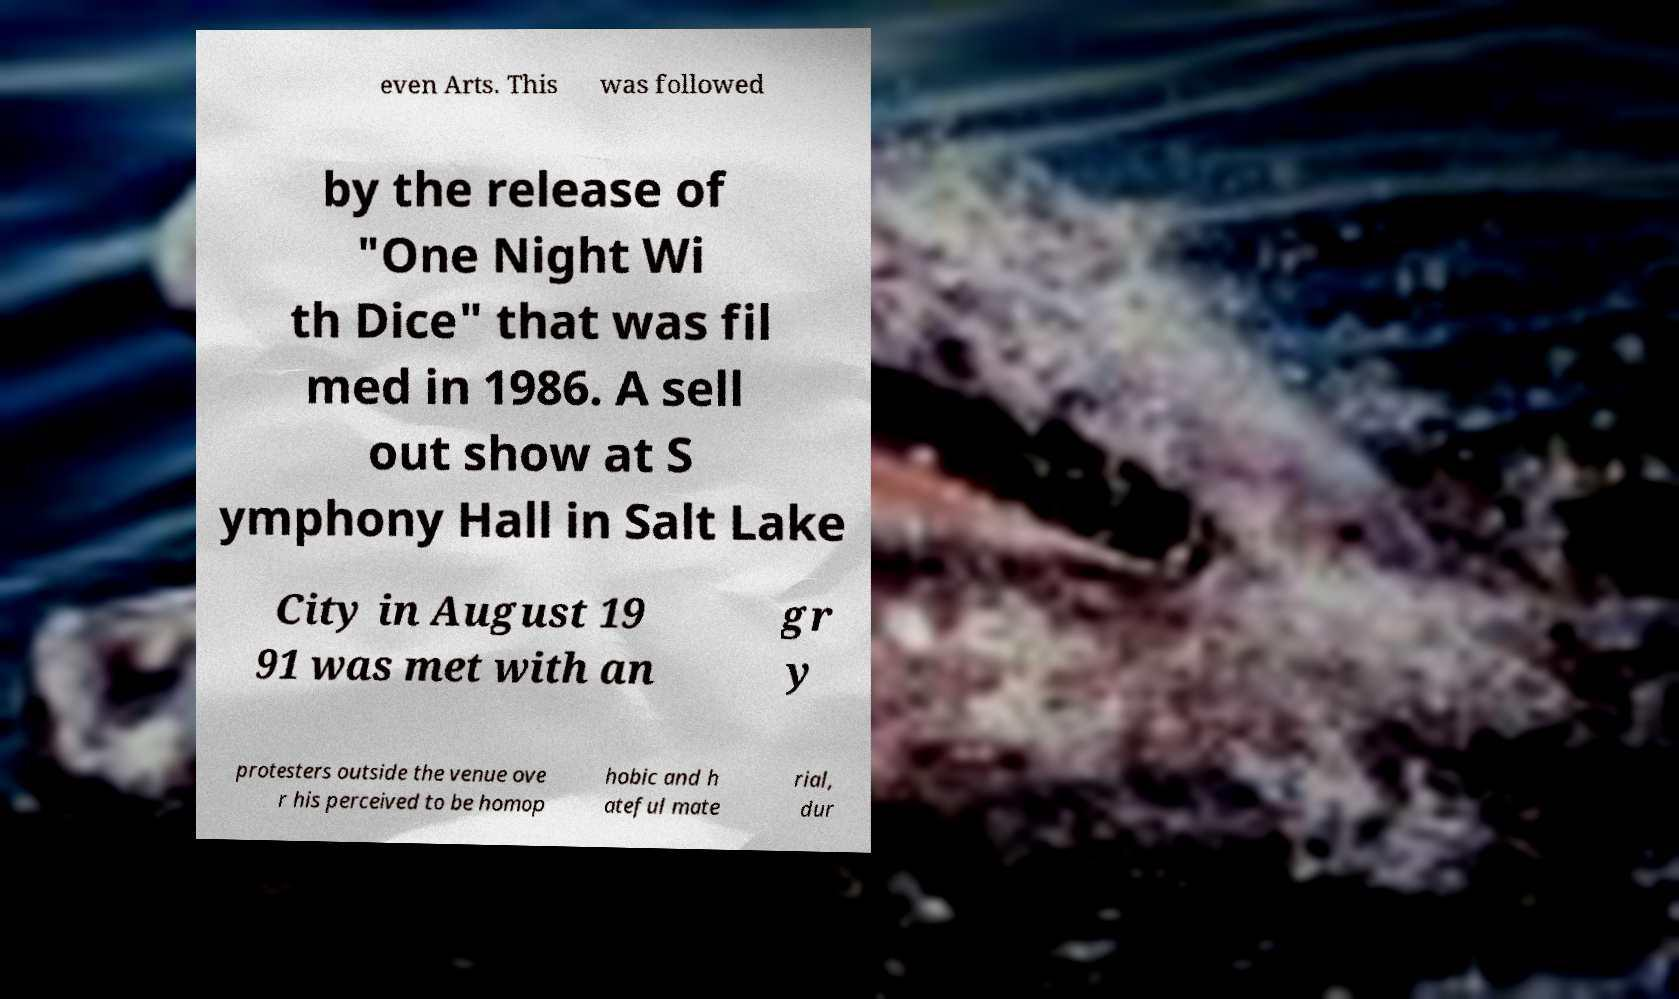There's text embedded in this image that I need extracted. Can you transcribe it verbatim? even Arts. This was followed by the release of "One Night Wi th Dice" that was fil med in 1986. A sell out show at S ymphony Hall in Salt Lake City in August 19 91 was met with an gr y protesters outside the venue ove r his perceived to be homop hobic and h ateful mate rial, dur 